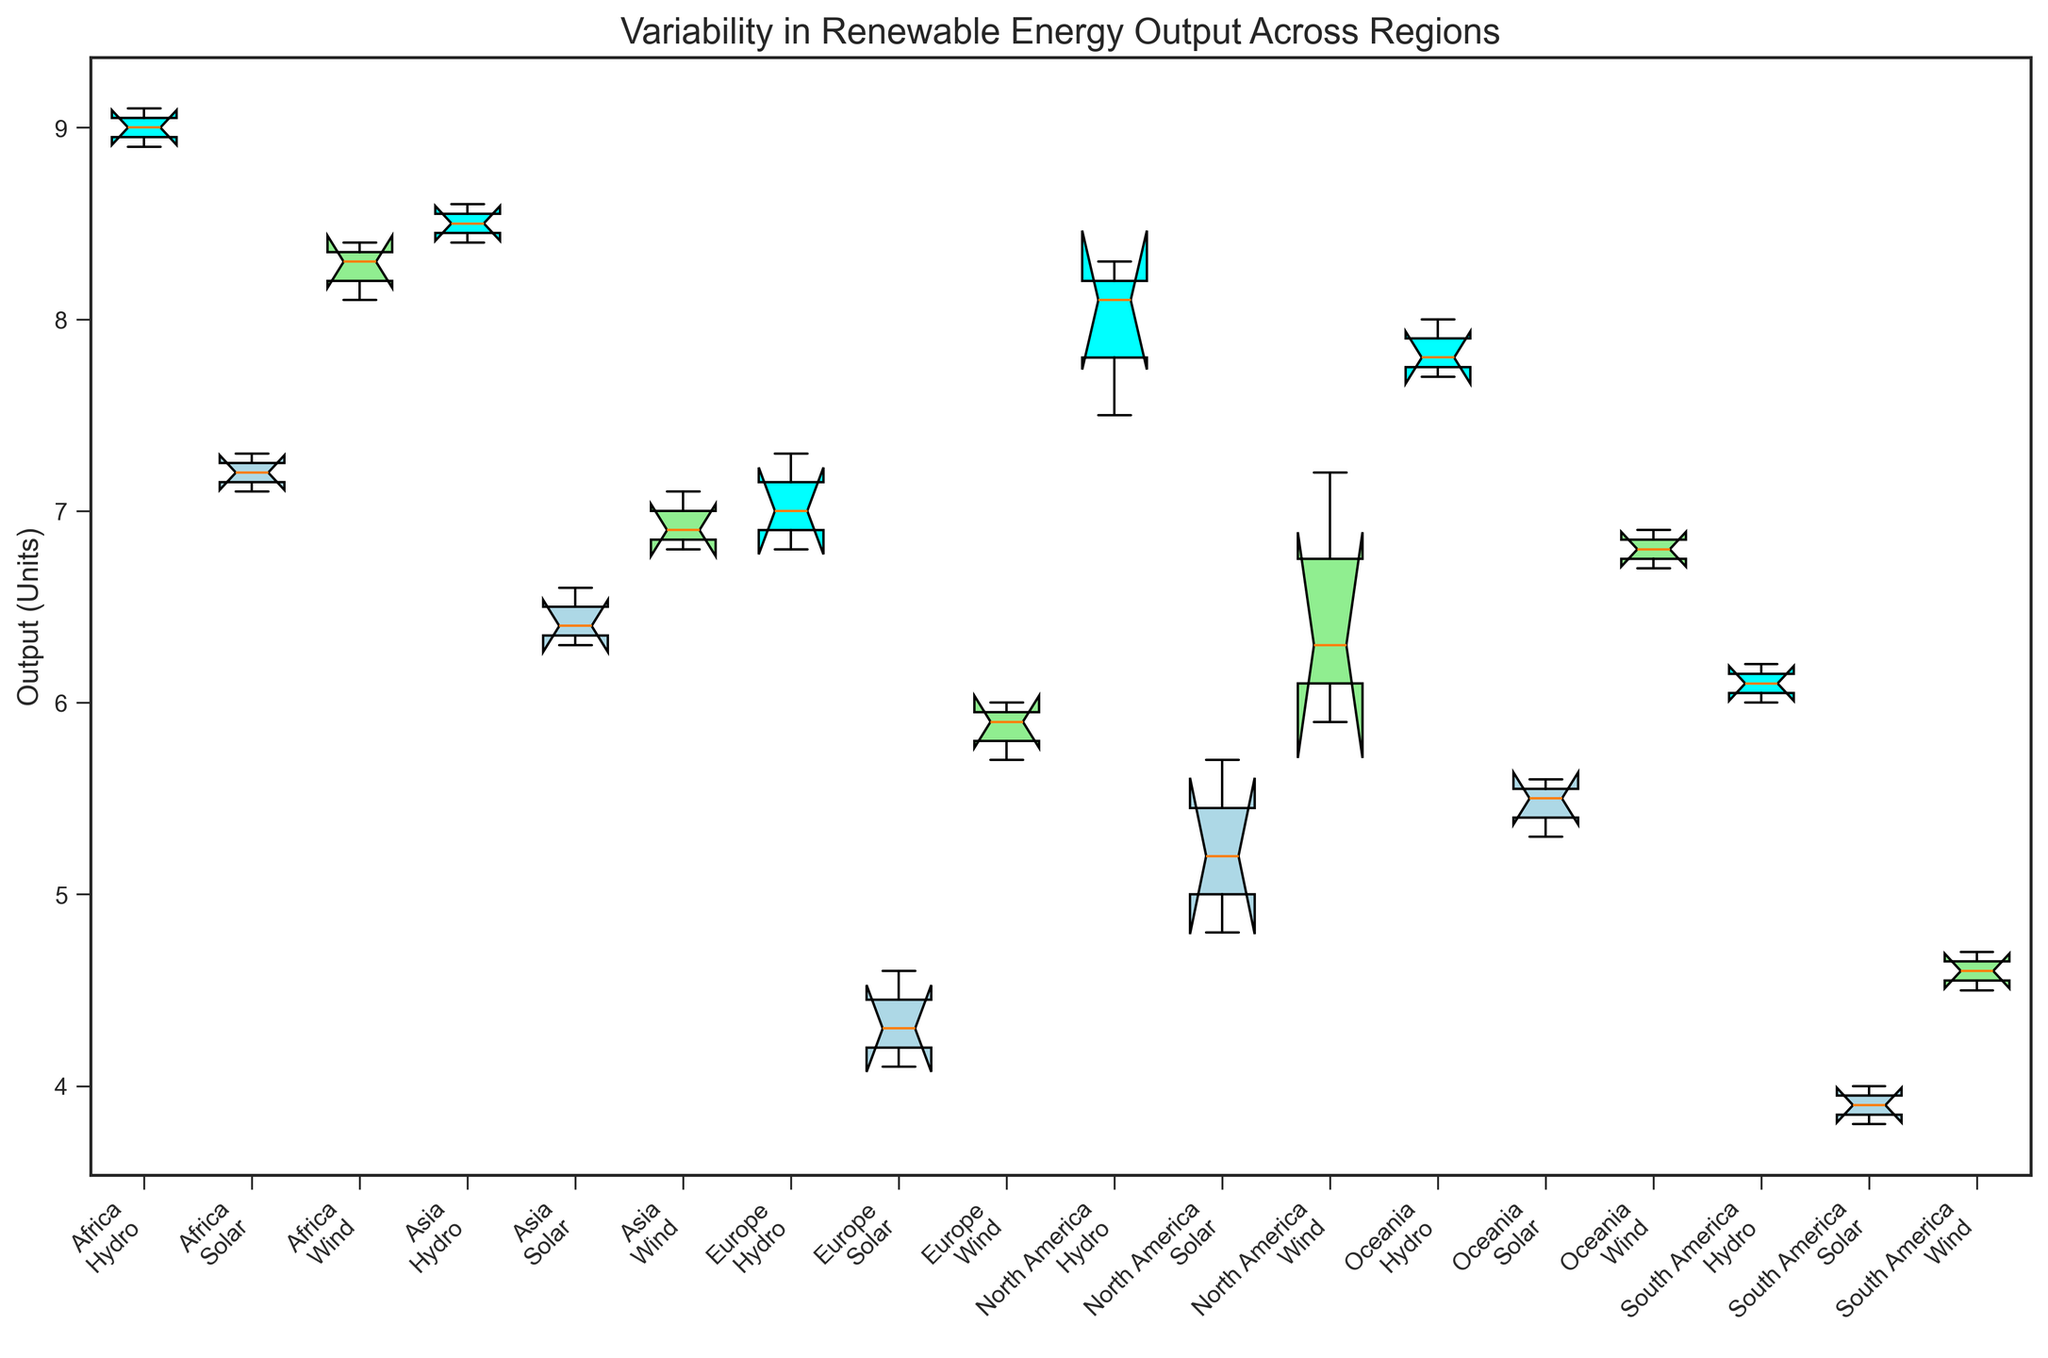What region has the highest median output for solar energy? Look at the medians of the solar energy outputs for each region. Africa shows the highest median output for solar energy as the center line of the box plot is at the highest position.
Answer: Africa Which energy source has the least variability in output across all regions? Compare the spread of the boxes (Interquartile Range, IQR) and the lengths of whiskers for each energy source across all regions. Hydro appears to have the least variability since its boxes have narrower widths in most regions compared to solar and wind.
Answer: Hydro What can be said about the output variability of wind energy in North America compared to Europe? Examine the spread (IQR) and length of whiskers of the box plots for wind energy in both North America and Europe. In North America, the whiskers are longer, and the box is more spread out compared to Europe, indicating higher variability.
Answer: North America shows higher variability Which regions show the lowest median output for hydro energy? Check the medians of hydro energy for each region. Both South America and Europe have the lower positions of medians, indicating the lowest median outputs among the regions.
Answer: South America and Europe In which region is the interquartile range (IQR) for solar energy the smallest? Examine the width of the box for solar energy for each region. Europe shows the smallest box width, indicating the smallest interquartile range (IQR).
Answer: Europe Which region shows the most consistent output for wind energy, based on the length of the whiskers? Look at the whisker lengths of wind energy for each region. South America has relatively short whiskers, indicating the most consistent output for wind energy.
Answer: South America How does the output of hydro energy in Africa compare to that in Oceania in terms of median values? Compare the median lines of the hydro energy box plots for Africa and Oceania. Africa's median line is higher, indicating a higher median output for hydro energy compared to Oceania.
Answer: Africa has a higher median What is the median output value for wind energy in Asia? Locate the center line of the wind energy box plot for Asia, which represents the median. The median line for Asia's wind energy seems to be at approximately 6.9.
Answer: 6.9 Which region has the highest variability in solar energy output? Examine the spread (IQR) and length of whiskers of the box plots for solar energy in each region. North America has the largest spread and longer whiskers, indicating the highest variability.
Answer: North America 